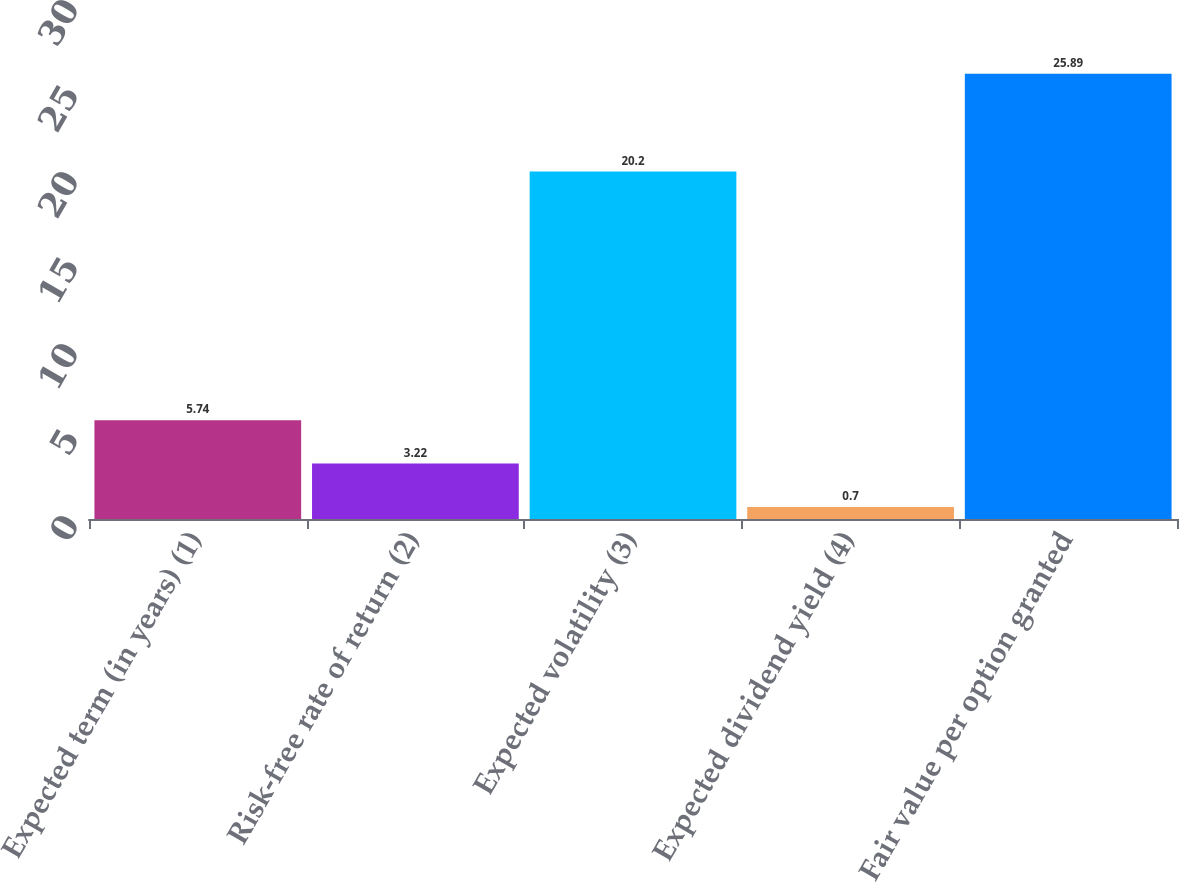Convert chart to OTSL. <chart><loc_0><loc_0><loc_500><loc_500><bar_chart><fcel>Expected term (in years) (1)<fcel>Risk-free rate of return (2)<fcel>Expected volatility (3)<fcel>Expected dividend yield (4)<fcel>Fair value per option granted<nl><fcel>5.74<fcel>3.22<fcel>20.2<fcel>0.7<fcel>25.89<nl></chart> 